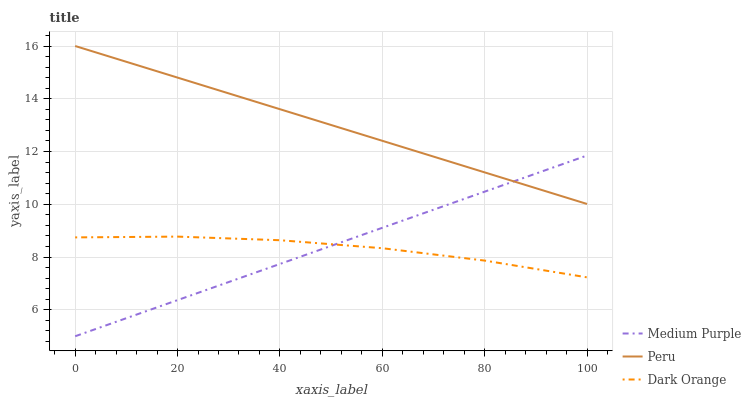Does Dark Orange have the minimum area under the curve?
Answer yes or no. Yes. Does Peru have the maximum area under the curve?
Answer yes or no. Yes. Does Peru have the minimum area under the curve?
Answer yes or no. No. Does Dark Orange have the maximum area under the curve?
Answer yes or no. No. Is Peru the smoothest?
Answer yes or no. Yes. Is Dark Orange the roughest?
Answer yes or no. Yes. Is Dark Orange the smoothest?
Answer yes or no. No. Is Peru the roughest?
Answer yes or no. No. Does Dark Orange have the lowest value?
Answer yes or no. No. Does Dark Orange have the highest value?
Answer yes or no. No. Is Dark Orange less than Peru?
Answer yes or no. Yes. Is Peru greater than Dark Orange?
Answer yes or no. Yes. Does Dark Orange intersect Peru?
Answer yes or no. No. 